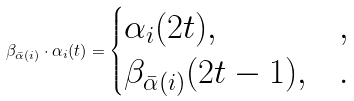<formula> <loc_0><loc_0><loc_500><loc_500>\beta _ { \bar { \alpha } ( i ) } \cdot \alpha _ { i } ( t ) = \begin{cases} \alpha _ { i } ( 2 t ) , & , \\ \beta _ { \bar { \alpha } ( i ) } ( 2 t - 1 ) , & . \end{cases}</formula> 